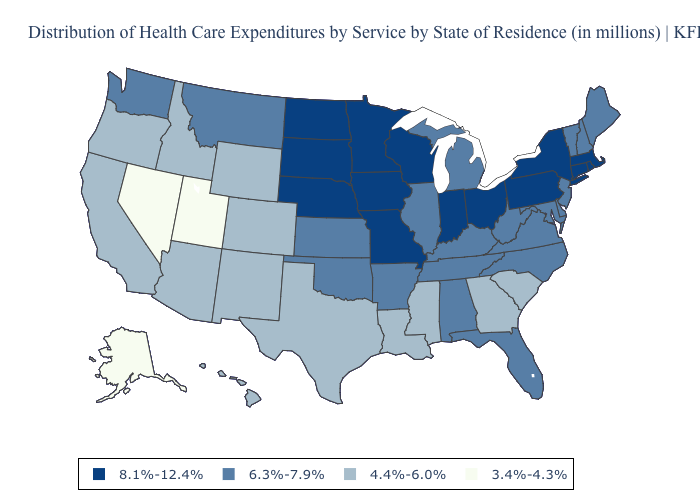Which states have the lowest value in the Northeast?
Quick response, please. Maine, New Hampshire, New Jersey, Vermont. What is the value of Rhode Island?
Short answer required. 8.1%-12.4%. Which states have the highest value in the USA?
Answer briefly. Connecticut, Indiana, Iowa, Massachusetts, Minnesota, Missouri, Nebraska, New York, North Dakota, Ohio, Pennsylvania, Rhode Island, South Dakota, Wisconsin. What is the highest value in the Northeast ?
Write a very short answer. 8.1%-12.4%. Does Kansas have a lower value than New Jersey?
Answer briefly. No. What is the highest value in states that border Montana?
Concise answer only. 8.1%-12.4%. Does Georgia have the highest value in the South?
Write a very short answer. No. Which states hav the highest value in the MidWest?
Answer briefly. Indiana, Iowa, Minnesota, Missouri, Nebraska, North Dakota, Ohio, South Dakota, Wisconsin. Does Texas have a lower value than Kansas?
Concise answer only. Yes. Name the states that have a value in the range 3.4%-4.3%?
Keep it brief. Alaska, Nevada, Utah. Among the states that border Texas , does Louisiana have the lowest value?
Be succinct. Yes. What is the value of Illinois?
Be succinct. 6.3%-7.9%. What is the value of Colorado?
Short answer required. 4.4%-6.0%. Does North Carolina have a higher value than Wisconsin?
Give a very brief answer. No. Which states hav the highest value in the West?
Short answer required. Montana, Washington. 